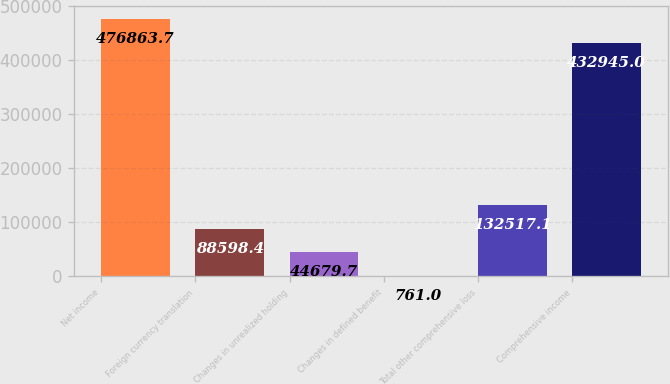Convert chart. <chart><loc_0><loc_0><loc_500><loc_500><bar_chart><fcel>Net income<fcel>Foreign currency translation<fcel>Changes in unrealized holding<fcel>Changes in defined benefit<fcel>Total other comprehensive loss<fcel>Comprehensive income<nl><fcel>476864<fcel>88598.4<fcel>44679.7<fcel>761<fcel>132517<fcel>432945<nl></chart> 